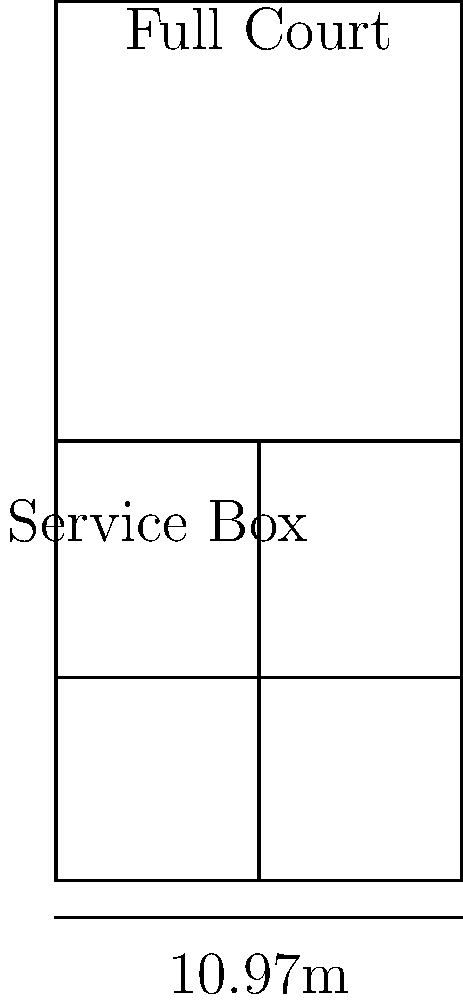In a tennis court, what is the ratio of the area of one service box to the area of the full court? Round your answer to two decimal places. Let's approach this step-by-step:

1. Calculate the area of the full court:
   Full court dimensions: 10.97m x 23.77m
   Area of full court = $10.97 \times 23.77 = 260.75$ sq m

2. Calculate the area of one service box:
   Service box dimensions: 5.485m x 6.4m (half of 11.885m - 5.485m)
   Area of one service box = $5.485 \times 6.4 = 35.104$ sq m

3. Calculate the ratio:
   Ratio = Area of service box / Area of full court
   $= 35.104 / 260.75 = 0.1346$

4. Round to two decimal places:
   $0.1346 \approx 0.13$

Therefore, the ratio of the area of one service box to the area of the full court is approximately 0.13 or 13%.
Answer: 0.13 